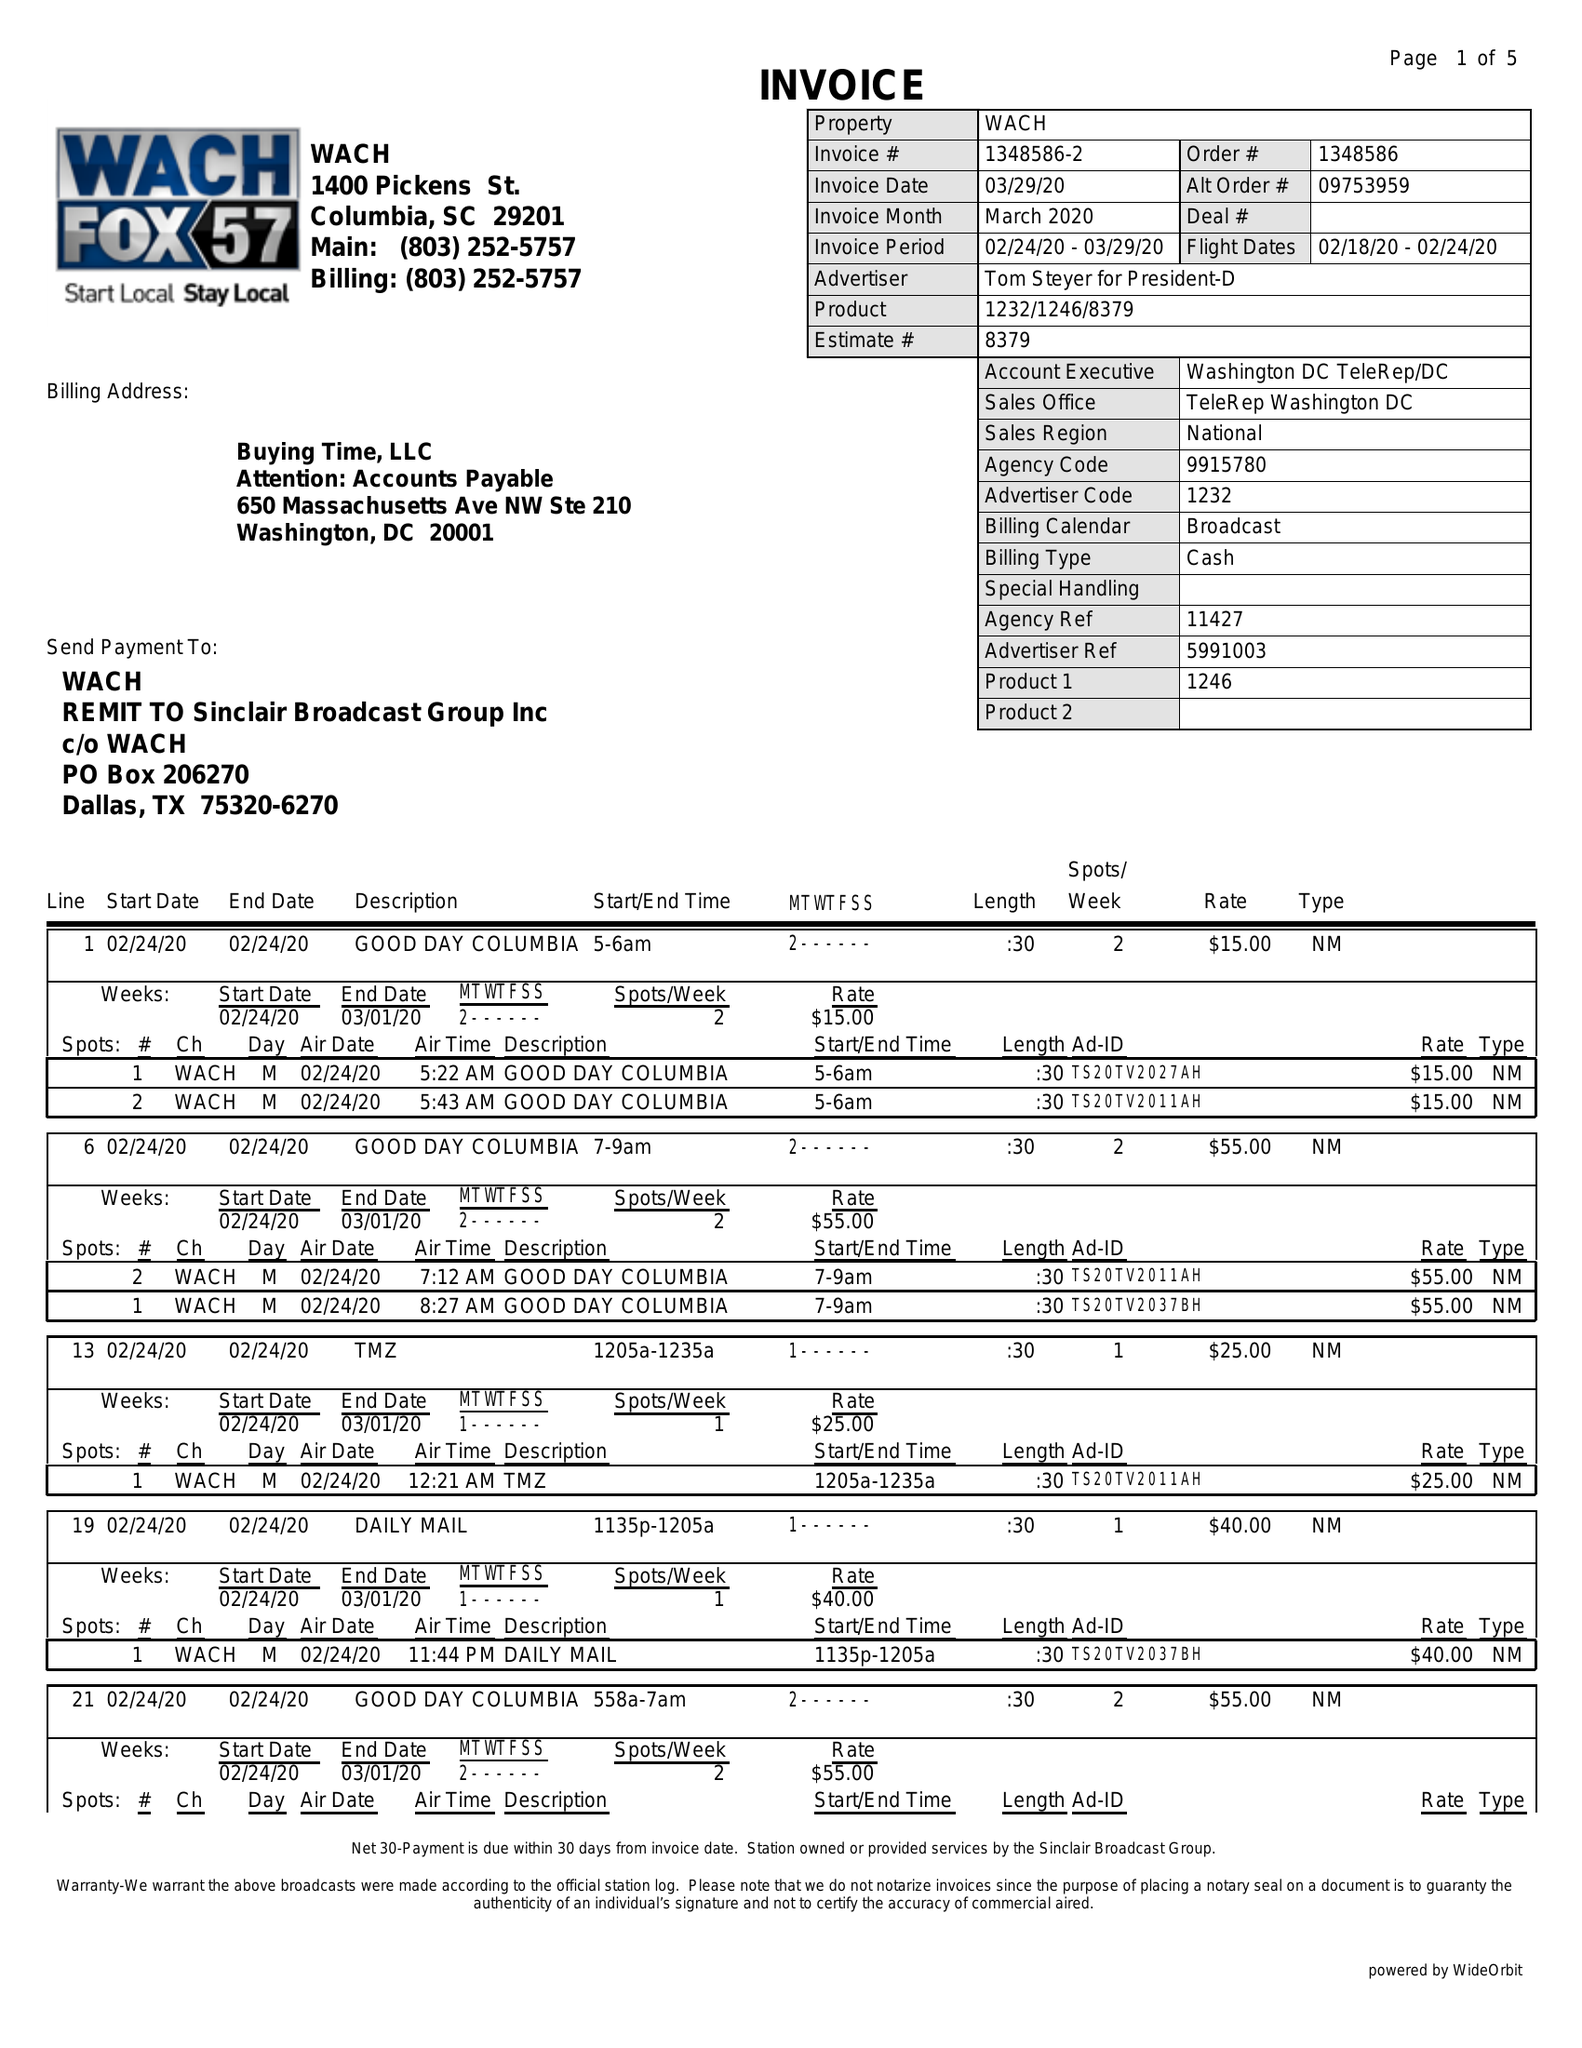What is the value for the advertiser?
Answer the question using a single word or phrase. TOM STEYER FOR PRESIDENT-D 